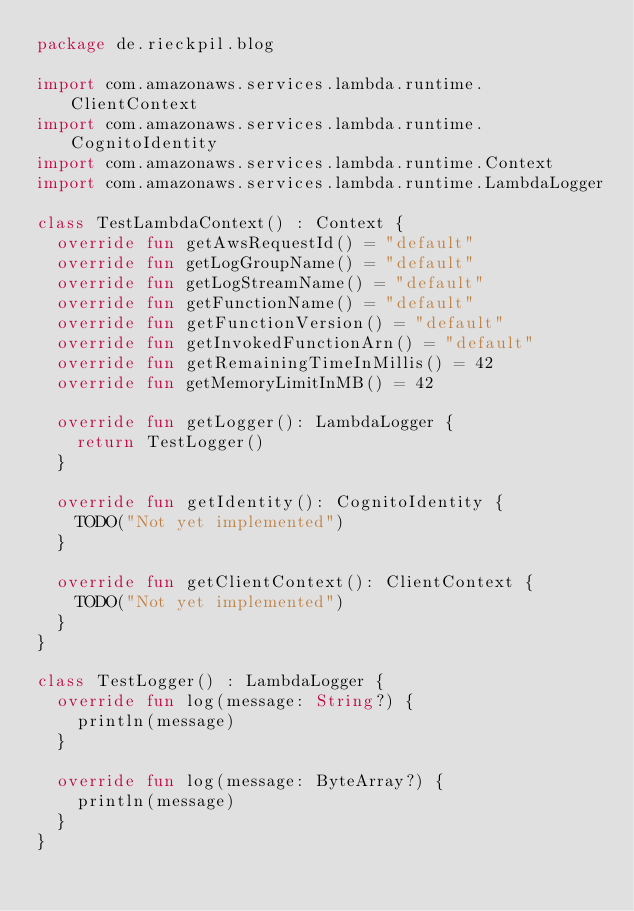Convert code to text. <code><loc_0><loc_0><loc_500><loc_500><_Kotlin_>package de.rieckpil.blog

import com.amazonaws.services.lambda.runtime.ClientContext
import com.amazonaws.services.lambda.runtime.CognitoIdentity
import com.amazonaws.services.lambda.runtime.Context
import com.amazonaws.services.lambda.runtime.LambdaLogger

class TestLambdaContext() : Context {
  override fun getAwsRequestId() = "default"
  override fun getLogGroupName() = "default"
  override fun getLogStreamName() = "default"
  override fun getFunctionName() = "default"
  override fun getFunctionVersion() = "default"
  override fun getInvokedFunctionArn() = "default"
  override fun getRemainingTimeInMillis() = 42
  override fun getMemoryLimitInMB() = 42

  override fun getLogger(): LambdaLogger {
    return TestLogger()
  }

  override fun getIdentity(): CognitoIdentity {
    TODO("Not yet implemented")
  }

  override fun getClientContext(): ClientContext {
    TODO("Not yet implemented")
  }
}

class TestLogger() : LambdaLogger {
  override fun log(message: String?) {
    println(message)
  }

  override fun log(message: ByteArray?) {
    println(message)
  }
}
</code> 